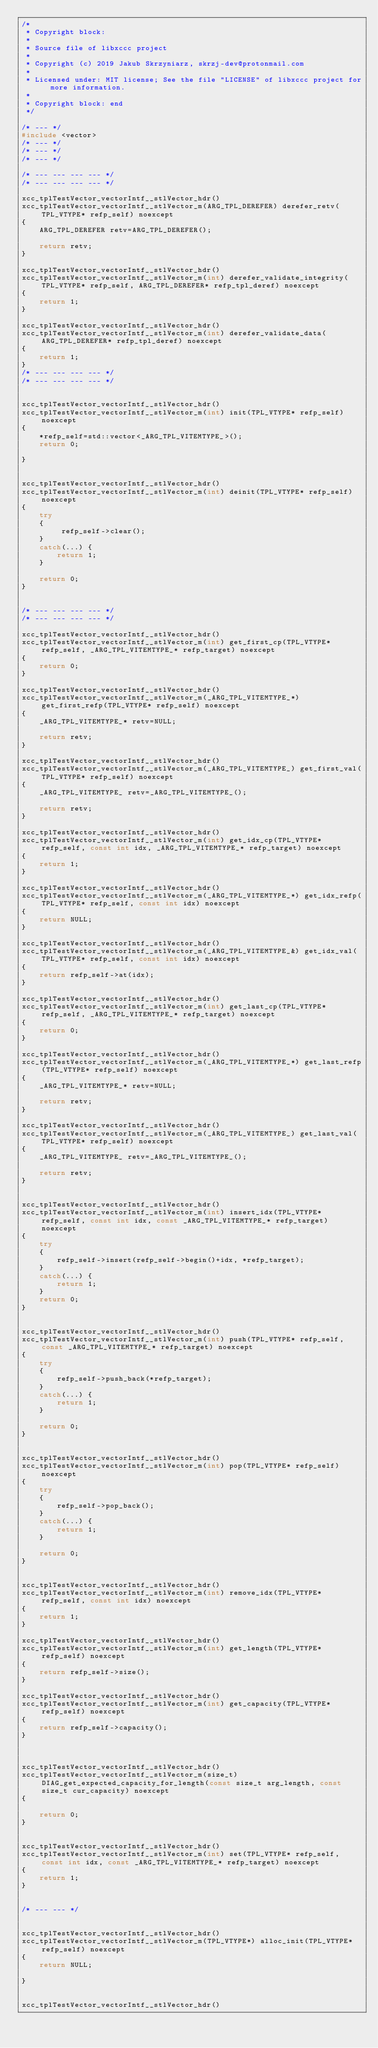<code> <loc_0><loc_0><loc_500><loc_500><_C++_>/*
 * Copyright block:
 *
 * Source file of libxccc project
 *
 * Copyright (c) 2019 Jakub Skrzyniarz, skrzj-dev@protonmail.com
 *
 * Licensed under: MIT license; See the file "LICENSE" of libxccc project for more information.
 *
 * Copyright block: end
 */

/* --- */
#include <vector>
/* --- */
/* --- */
/* --- */

/* --- --- --- --- */
/* --- --- --- --- */

xcc_tplTestVector_vectorIntf__stlVector_hdr()
xcc_tplTestVector_vectorIntf__stlVector_m(ARG_TPL_DEREFER) derefer_retv(TPL_VTYPE* refp_self) noexcept
{
	ARG_TPL_DEREFER retv=ARG_TPL_DEREFER();
	
	return retv;
}

xcc_tplTestVector_vectorIntf__stlVector_hdr()
xcc_tplTestVector_vectorIntf__stlVector_m(int) derefer_validate_integrity(TPL_VTYPE* refp_self, ARG_TPL_DEREFER* refp_tpl_deref) noexcept
{
	return 1;
}

xcc_tplTestVector_vectorIntf__stlVector_hdr()
xcc_tplTestVector_vectorIntf__stlVector_m(int) derefer_validate_data(ARG_TPL_DEREFER* refp_tpl_deref) noexcept
{
	return 1;
}
/* --- --- --- --- */
/* --- --- --- --- */


xcc_tplTestVector_vectorIntf__stlVector_hdr()
xcc_tplTestVector_vectorIntf__stlVector_m(int) init(TPL_VTYPE* refp_self) noexcept
{
	*refp_self=std::vector<_ARG_TPL_VITEMTYPE_>();
	return 0;
	
}


xcc_tplTestVector_vectorIntf__stlVector_hdr()
xcc_tplTestVector_vectorIntf__stlVector_m(int) deinit(TPL_VTYPE* refp_self) noexcept
{
	try
	{
		 refp_self->clear();
	}
	catch(...) {
		return 1;
	}
	
	return 0;
}


/* --- --- --- --- */
/* --- --- --- --- */

xcc_tplTestVector_vectorIntf__stlVector_hdr()
xcc_tplTestVector_vectorIntf__stlVector_m(int) get_first_cp(TPL_VTYPE* refp_self, _ARG_TPL_VITEMTYPE_* refp_target) noexcept
{
	return 0;
}

xcc_tplTestVector_vectorIntf__stlVector_hdr()
xcc_tplTestVector_vectorIntf__stlVector_m(_ARG_TPL_VITEMTYPE_*) get_first_refp(TPL_VTYPE* refp_self) noexcept
{
	_ARG_TPL_VITEMTYPE_* retv=NULL;
	
	return retv;
}

xcc_tplTestVector_vectorIntf__stlVector_hdr()
xcc_tplTestVector_vectorIntf__stlVector_m(_ARG_TPL_VITEMTYPE_) get_first_val(TPL_VTYPE* refp_self) noexcept
{
	_ARG_TPL_VITEMTYPE_ retv=_ARG_TPL_VITEMTYPE_();
	
	return retv;
}

xcc_tplTestVector_vectorIntf__stlVector_hdr()
xcc_tplTestVector_vectorIntf__stlVector_m(int) get_idx_cp(TPL_VTYPE* refp_self, const int idx, _ARG_TPL_VITEMTYPE_* refp_target) noexcept
{
	return 1;
}

xcc_tplTestVector_vectorIntf__stlVector_hdr()
xcc_tplTestVector_vectorIntf__stlVector_m(_ARG_TPL_VITEMTYPE_*) get_idx_refp(TPL_VTYPE* refp_self, const int idx) noexcept
{
	return NULL;
}

xcc_tplTestVector_vectorIntf__stlVector_hdr()
xcc_tplTestVector_vectorIntf__stlVector_m(_ARG_TPL_VITEMTYPE_&) get_idx_val(TPL_VTYPE* refp_self, const int idx) noexcept
{
	return refp_self->at(idx);
}

xcc_tplTestVector_vectorIntf__stlVector_hdr()
xcc_tplTestVector_vectorIntf__stlVector_m(int) get_last_cp(TPL_VTYPE* refp_self, _ARG_TPL_VITEMTYPE_* refp_target) noexcept
{
	return 0;
}

xcc_tplTestVector_vectorIntf__stlVector_hdr()
xcc_tplTestVector_vectorIntf__stlVector_m(_ARG_TPL_VITEMTYPE_*) get_last_refp(TPL_VTYPE* refp_self) noexcept
{
	_ARG_TPL_VITEMTYPE_* retv=NULL;
	
	return retv;
}

xcc_tplTestVector_vectorIntf__stlVector_hdr()
xcc_tplTestVector_vectorIntf__stlVector_m(_ARG_TPL_VITEMTYPE_) get_last_val(TPL_VTYPE* refp_self) noexcept
{
	_ARG_TPL_VITEMTYPE_ retv=_ARG_TPL_VITEMTYPE_();
	
	return retv;
}


xcc_tplTestVector_vectorIntf__stlVector_hdr()
xcc_tplTestVector_vectorIntf__stlVector_m(int) insert_idx(TPL_VTYPE* refp_self, const int idx, const _ARG_TPL_VITEMTYPE_* refp_target) noexcept
{
	try
	{
		refp_self->insert(refp_self->begin()+idx, *refp_target);
	}
	catch(...) {
		return 1;
	}
	return 0;
}


xcc_tplTestVector_vectorIntf__stlVector_hdr()
xcc_tplTestVector_vectorIntf__stlVector_m(int) push(TPL_VTYPE* refp_self, const _ARG_TPL_VITEMTYPE_* refp_target) noexcept
{
	try
	{
		refp_self->push_back(*refp_target);
	}
	catch(...) {
		return 1;
	}
	
	return 0;
}


xcc_tplTestVector_vectorIntf__stlVector_hdr()
xcc_tplTestVector_vectorIntf__stlVector_m(int) pop(TPL_VTYPE* refp_self) noexcept
{
	try
	{
		refp_self->pop_back();
	}
	catch(...) {
		return 1;
	}
	
	return 0;
}


xcc_tplTestVector_vectorIntf__stlVector_hdr()
xcc_tplTestVector_vectorIntf__stlVector_m(int) remove_idx(TPL_VTYPE* refp_self, const int idx) noexcept
{
	return 1;
}

xcc_tplTestVector_vectorIntf__stlVector_hdr()
xcc_tplTestVector_vectorIntf__stlVector_m(int) get_length(TPL_VTYPE* refp_self) noexcept
{
	return refp_self->size();
}

xcc_tplTestVector_vectorIntf__stlVector_hdr()
xcc_tplTestVector_vectorIntf__stlVector_m(int) get_capacity(TPL_VTYPE* refp_self) noexcept
{
	return refp_self->capacity();
}



xcc_tplTestVector_vectorIntf__stlVector_hdr()
xcc_tplTestVector_vectorIntf__stlVector_m(size_t) DIAG_get_expected_capacity_for_length(const size_t arg_length, const size_t cur_capacity) noexcept
{

	return 0;
}


xcc_tplTestVector_vectorIntf__stlVector_hdr()
xcc_tplTestVector_vectorIntf__stlVector_m(int) set(TPL_VTYPE* refp_self, const int idx, const _ARG_TPL_VITEMTYPE_* refp_target) noexcept
{
	return 1;
}


/* --- --- */


xcc_tplTestVector_vectorIntf__stlVector_hdr()
xcc_tplTestVector_vectorIntf__stlVector_m(TPL_VTYPE*) alloc_init(TPL_VTYPE* refp_self) noexcept
{
	return NULL;
	
}


xcc_tplTestVector_vectorIntf__stlVector_hdr()</code> 